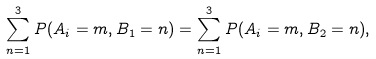Convert formula to latex. <formula><loc_0><loc_0><loc_500><loc_500>\sum _ { n = 1 } ^ { 3 } P ( A _ { i } = m , B _ { 1 } = n ) = \sum _ { n = 1 } ^ { 3 } P ( A _ { i } = m , B _ { 2 } = n ) ,</formula> 